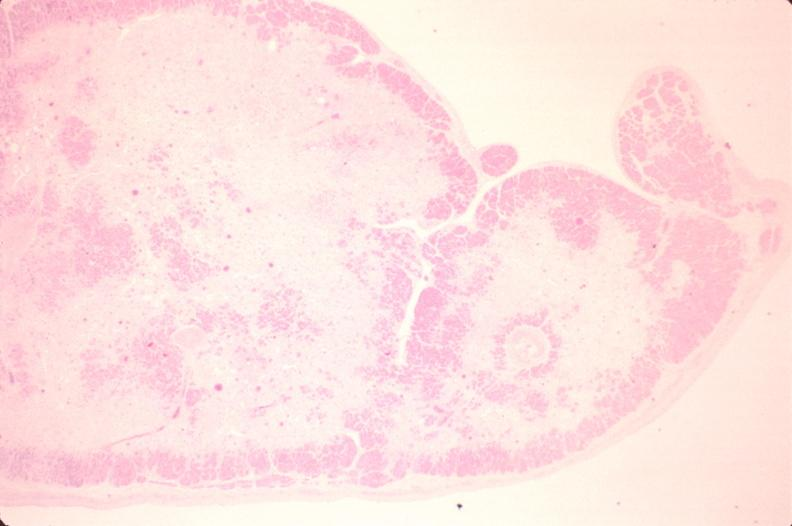s cardiovascular present?
Answer the question using a single word or phrase. Yes 